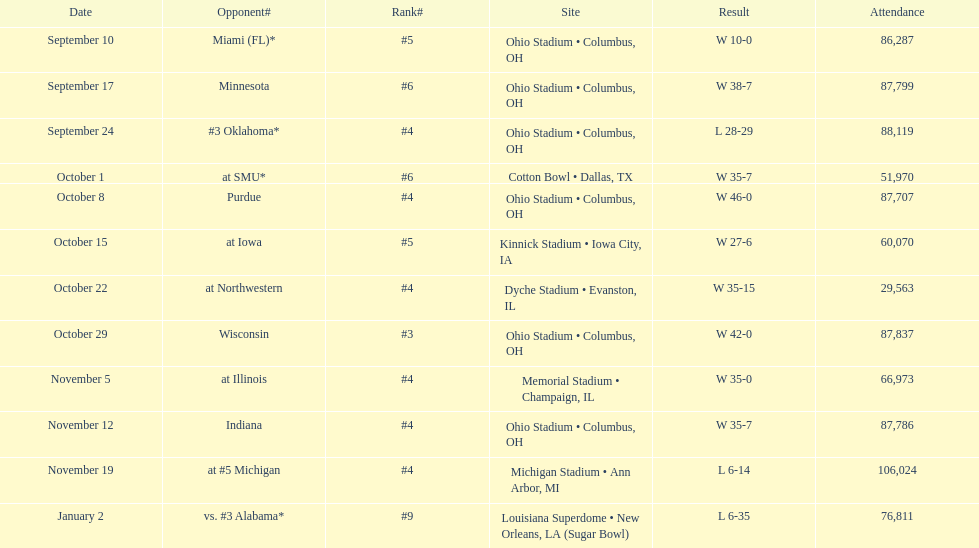In how many games did the attendance exceed 80,000 people? 7. 